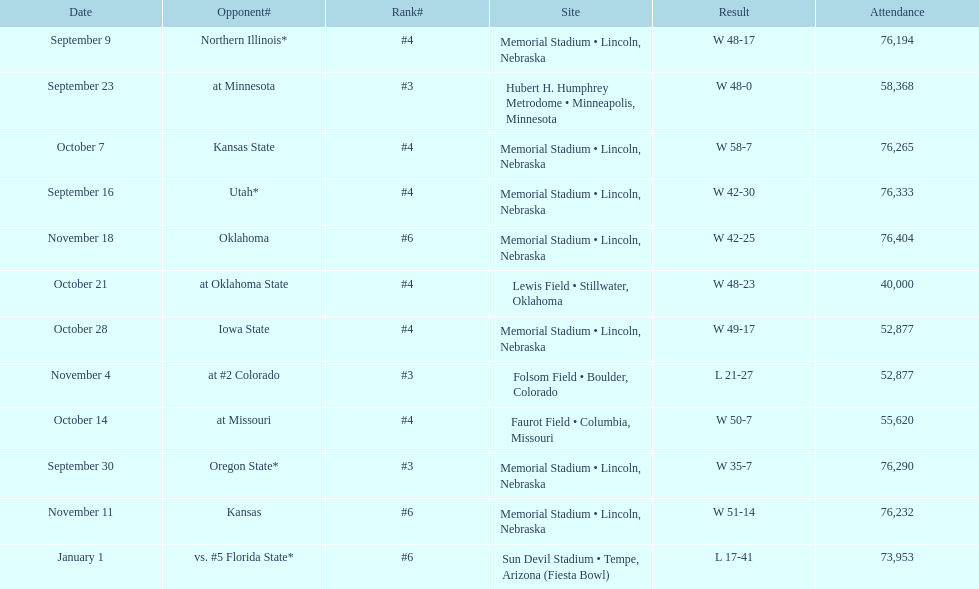How many games was their ranking not lower than #5? 9. 